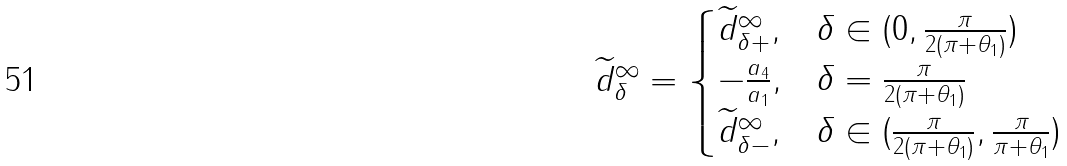Convert formula to latex. <formula><loc_0><loc_0><loc_500><loc_500>\widetilde { d } _ { \delta } ^ { \infty } = \begin{cases} \widetilde { d } _ { \delta + } ^ { \infty } , & \delta \in ( 0 , \frac { \pi } { 2 ( \pi + \theta _ { 1 } ) } ) \\ - \frac { a _ { 4 } } { a _ { 1 } } , & \delta = \frac { \pi } { 2 ( \pi + \theta _ { 1 } ) } \\ \widetilde { d } _ { \delta - } ^ { \infty } , & \delta \in ( \frac { \pi } { 2 ( \pi + \theta _ { 1 } ) } , \frac { \pi } { \pi + \theta _ { 1 } } ) \\ \end{cases}</formula> 